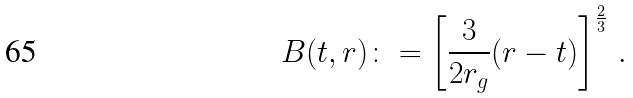Convert formula to latex. <formula><loc_0><loc_0><loc_500><loc_500>B ( t , r ) \colon = \left [ \frac { 3 } { 2 r _ { g } } ( r - t ) \right ] ^ { \frac { 2 } { 3 } } \, .</formula> 